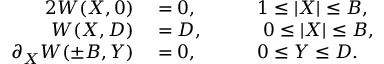Convert formula to latex. <formula><loc_0><loc_0><loc_500><loc_500>\begin{array} { r l r l } { { 2 } W ( X , 0 ) } & = 0 , } & { \quad } & 1 \leq | X | \leq B , } \\ { W ( X , D ) } & = D , } & \ 0 \leq | X | \leq B , } \\ { \partial _ { X } W ( \pm B , Y ) } & = 0 , } & 0 \leq Y \leq D . } \end{array}</formula> 